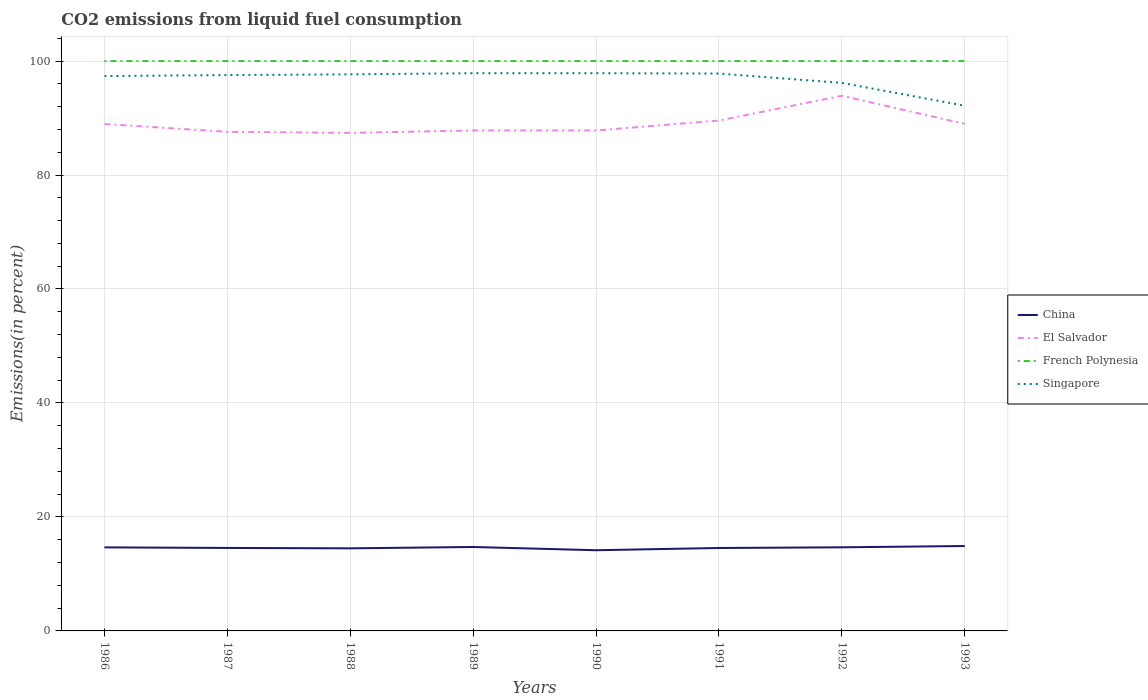How many different coloured lines are there?
Ensure brevity in your answer.  4. Does the line corresponding to Singapore intersect with the line corresponding to China?
Provide a succinct answer. No. Across all years, what is the maximum total CO2 emitted in China?
Your response must be concise. 14.16. What is the total total CO2 emitted in China in the graph?
Ensure brevity in your answer.  -0.34. What is the difference between the highest and the second highest total CO2 emitted in Singapore?
Provide a succinct answer. 5.71. What is the difference between the highest and the lowest total CO2 emitted in China?
Ensure brevity in your answer.  4. What is the difference between two consecutive major ticks on the Y-axis?
Keep it short and to the point. 20. Are the values on the major ticks of Y-axis written in scientific E-notation?
Provide a short and direct response. No. Does the graph contain grids?
Give a very brief answer. Yes. Where does the legend appear in the graph?
Give a very brief answer. Center right. How are the legend labels stacked?
Keep it short and to the point. Vertical. What is the title of the graph?
Give a very brief answer. CO2 emissions from liquid fuel consumption. Does "Turkmenistan" appear as one of the legend labels in the graph?
Provide a succinct answer. No. What is the label or title of the Y-axis?
Offer a very short reply. Emissions(in percent). What is the Emissions(in percent) in China in 1986?
Make the answer very short. 14.66. What is the Emissions(in percent) in El Salvador in 1986?
Offer a terse response. 88.95. What is the Emissions(in percent) in Singapore in 1986?
Your answer should be very brief. 97.36. What is the Emissions(in percent) in China in 1987?
Your answer should be very brief. 14.56. What is the Emissions(in percent) in El Salvador in 1987?
Your answer should be compact. 87.57. What is the Emissions(in percent) of French Polynesia in 1987?
Give a very brief answer. 100. What is the Emissions(in percent) in Singapore in 1987?
Provide a short and direct response. 97.54. What is the Emissions(in percent) of China in 1988?
Keep it short and to the point. 14.49. What is the Emissions(in percent) in El Salvador in 1988?
Your answer should be very brief. 87.39. What is the Emissions(in percent) of Singapore in 1988?
Keep it short and to the point. 97.66. What is the Emissions(in percent) of China in 1989?
Give a very brief answer. 14.73. What is the Emissions(in percent) in El Salvador in 1989?
Make the answer very short. 87.82. What is the Emissions(in percent) of French Polynesia in 1989?
Offer a terse response. 100. What is the Emissions(in percent) of Singapore in 1989?
Provide a succinct answer. 97.86. What is the Emissions(in percent) of China in 1990?
Ensure brevity in your answer.  14.16. What is the Emissions(in percent) in El Salvador in 1990?
Offer a terse response. 87.82. What is the Emissions(in percent) of French Polynesia in 1990?
Ensure brevity in your answer.  100. What is the Emissions(in percent) of Singapore in 1990?
Your response must be concise. 97.87. What is the Emissions(in percent) of China in 1991?
Make the answer very short. 14.55. What is the Emissions(in percent) in El Salvador in 1991?
Provide a succinct answer. 89.56. What is the Emissions(in percent) in French Polynesia in 1991?
Your answer should be very brief. 100. What is the Emissions(in percent) of Singapore in 1991?
Keep it short and to the point. 97.8. What is the Emissions(in percent) in China in 1992?
Ensure brevity in your answer.  14.67. What is the Emissions(in percent) in El Salvador in 1992?
Provide a short and direct response. 93.9. What is the Emissions(in percent) in Singapore in 1992?
Make the answer very short. 96.16. What is the Emissions(in percent) in China in 1993?
Offer a terse response. 14.9. What is the Emissions(in percent) of El Salvador in 1993?
Provide a short and direct response. 88.97. What is the Emissions(in percent) of French Polynesia in 1993?
Ensure brevity in your answer.  100. What is the Emissions(in percent) of Singapore in 1993?
Offer a terse response. 92.15. Across all years, what is the maximum Emissions(in percent) of China?
Provide a short and direct response. 14.9. Across all years, what is the maximum Emissions(in percent) in El Salvador?
Offer a very short reply. 93.9. Across all years, what is the maximum Emissions(in percent) in French Polynesia?
Give a very brief answer. 100. Across all years, what is the maximum Emissions(in percent) in Singapore?
Your response must be concise. 97.87. Across all years, what is the minimum Emissions(in percent) of China?
Provide a short and direct response. 14.16. Across all years, what is the minimum Emissions(in percent) of El Salvador?
Offer a terse response. 87.39. Across all years, what is the minimum Emissions(in percent) in Singapore?
Your answer should be very brief. 92.15. What is the total Emissions(in percent) of China in the graph?
Your response must be concise. 116.73. What is the total Emissions(in percent) of El Salvador in the graph?
Ensure brevity in your answer.  711.98. What is the total Emissions(in percent) of French Polynesia in the graph?
Give a very brief answer. 800. What is the total Emissions(in percent) of Singapore in the graph?
Your response must be concise. 774.41. What is the difference between the Emissions(in percent) in China in 1986 and that in 1987?
Your answer should be very brief. 0.1. What is the difference between the Emissions(in percent) in El Salvador in 1986 and that in 1987?
Make the answer very short. 1.38. What is the difference between the Emissions(in percent) of French Polynesia in 1986 and that in 1987?
Your response must be concise. 0. What is the difference between the Emissions(in percent) in Singapore in 1986 and that in 1987?
Keep it short and to the point. -0.17. What is the difference between the Emissions(in percent) of China in 1986 and that in 1988?
Provide a short and direct response. 0.17. What is the difference between the Emissions(in percent) of El Salvador in 1986 and that in 1988?
Your answer should be compact. 1.56. What is the difference between the Emissions(in percent) of French Polynesia in 1986 and that in 1988?
Give a very brief answer. 0. What is the difference between the Emissions(in percent) in Singapore in 1986 and that in 1988?
Offer a terse response. -0.3. What is the difference between the Emissions(in percent) of China in 1986 and that in 1989?
Your response must be concise. -0.07. What is the difference between the Emissions(in percent) of El Salvador in 1986 and that in 1989?
Make the answer very short. 1.13. What is the difference between the Emissions(in percent) of French Polynesia in 1986 and that in 1989?
Keep it short and to the point. 0. What is the difference between the Emissions(in percent) in Singapore in 1986 and that in 1989?
Provide a succinct answer. -0.5. What is the difference between the Emissions(in percent) in China in 1986 and that in 1990?
Offer a very short reply. 0.5. What is the difference between the Emissions(in percent) in El Salvador in 1986 and that in 1990?
Keep it short and to the point. 1.14. What is the difference between the Emissions(in percent) of French Polynesia in 1986 and that in 1990?
Provide a succinct answer. 0. What is the difference between the Emissions(in percent) in Singapore in 1986 and that in 1990?
Your response must be concise. -0.51. What is the difference between the Emissions(in percent) in China in 1986 and that in 1991?
Keep it short and to the point. 0.11. What is the difference between the Emissions(in percent) in El Salvador in 1986 and that in 1991?
Make the answer very short. -0.61. What is the difference between the Emissions(in percent) in French Polynesia in 1986 and that in 1991?
Your answer should be very brief. 0. What is the difference between the Emissions(in percent) in Singapore in 1986 and that in 1991?
Keep it short and to the point. -0.44. What is the difference between the Emissions(in percent) in China in 1986 and that in 1992?
Provide a succinct answer. -0.01. What is the difference between the Emissions(in percent) in El Salvador in 1986 and that in 1992?
Your response must be concise. -4.95. What is the difference between the Emissions(in percent) in Singapore in 1986 and that in 1992?
Give a very brief answer. 1.2. What is the difference between the Emissions(in percent) of China in 1986 and that in 1993?
Your answer should be compact. -0.24. What is the difference between the Emissions(in percent) in El Salvador in 1986 and that in 1993?
Your response must be concise. -0.02. What is the difference between the Emissions(in percent) of Singapore in 1986 and that in 1993?
Your answer should be very brief. 5.21. What is the difference between the Emissions(in percent) of China in 1987 and that in 1988?
Give a very brief answer. 0.07. What is the difference between the Emissions(in percent) of El Salvador in 1987 and that in 1988?
Your response must be concise. 0.19. What is the difference between the Emissions(in percent) in Singapore in 1987 and that in 1988?
Your answer should be very brief. -0.13. What is the difference between the Emissions(in percent) of China in 1987 and that in 1989?
Your answer should be very brief. -0.17. What is the difference between the Emissions(in percent) in El Salvador in 1987 and that in 1989?
Your answer should be very brief. -0.24. What is the difference between the Emissions(in percent) of Singapore in 1987 and that in 1989?
Your response must be concise. -0.33. What is the difference between the Emissions(in percent) of China in 1987 and that in 1990?
Give a very brief answer. 0.4. What is the difference between the Emissions(in percent) in El Salvador in 1987 and that in 1990?
Offer a very short reply. -0.24. What is the difference between the Emissions(in percent) in Singapore in 1987 and that in 1990?
Your answer should be compact. -0.33. What is the difference between the Emissions(in percent) in China in 1987 and that in 1991?
Provide a succinct answer. 0.01. What is the difference between the Emissions(in percent) of El Salvador in 1987 and that in 1991?
Keep it short and to the point. -1.98. What is the difference between the Emissions(in percent) of Singapore in 1987 and that in 1991?
Make the answer very short. -0.27. What is the difference between the Emissions(in percent) in China in 1987 and that in 1992?
Provide a succinct answer. -0.11. What is the difference between the Emissions(in percent) of El Salvador in 1987 and that in 1992?
Your answer should be very brief. -6.33. What is the difference between the Emissions(in percent) in Singapore in 1987 and that in 1992?
Keep it short and to the point. 1.37. What is the difference between the Emissions(in percent) of China in 1987 and that in 1993?
Make the answer very short. -0.34. What is the difference between the Emissions(in percent) of El Salvador in 1987 and that in 1993?
Offer a terse response. -1.4. What is the difference between the Emissions(in percent) of French Polynesia in 1987 and that in 1993?
Offer a very short reply. 0. What is the difference between the Emissions(in percent) of Singapore in 1987 and that in 1993?
Provide a short and direct response. 5.38. What is the difference between the Emissions(in percent) in China in 1988 and that in 1989?
Your answer should be very brief. -0.24. What is the difference between the Emissions(in percent) of El Salvador in 1988 and that in 1989?
Offer a very short reply. -0.43. What is the difference between the Emissions(in percent) in French Polynesia in 1988 and that in 1989?
Keep it short and to the point. 0. What is the difference between the Emissions(in percent) in Singapore in 1988 and that in 1989?
Provide a succinct answer. -0.2. What is the difference between the Emissions(in percent) in China in 1988 and that in 1990?
Keep it short and to the point. 0.34. What is the difference between the Emissions(in percent) of El Salvador in 1988 and that in 1990?
Provide a succinct answer. -0.43. What is the difference between the Emissions(in percent) in Singapore in 1988 and that in 1990?
Ensure brevity in your answer.  -0.2. What is the difference between the Emissions(in percent) of China in 1988 and that in 1991?
Your answer should be very brief. -0.06. What is the difference between the Emissions(in percent) of El Salvador in 1988 and that in 1991?
Offer a terse response. -2.17. What is the difference between the Emissions(in percent) of Singapore in 1988 and that in 1991?
Keep it short and to the point. -0.14. What is the difference between the Emissions(in percent) of China in 1988 and that in 1992?
Provide a succinct answer. -0.18. What is the difference between the Emissions(in percent) in El Salvador in 1988 and that in 1992?
Provide a succinct answer. -6.51. What is the difference between the Emissions(in percent) of French Polynesia in 1988 and that in 1992?
Your answer should be compact. 0. What is the difference between the Emissions(in percent) in Singapore in 1988 and that in 1992?
Provide a short and direct response. 1.5. What is the difference between the Emissions(in percent) in China in 1988 and that in 1993?
Provide a short and direct response. -0.41. What is the difference between the Emissions(in percent) in El Salvador in 1988 and that in 1993?
Your answer should be very brief. -1.58. What is the difference between the Emissions(in percent) of Singapore in 1988 and that in 1993?
Provide a short and direct response. 5.51. What is the difference between the Emissions(in percent) of China in 1989 and that in 1990?
Offer a terse response. 0.57. What is the difference between the Emissions(in percent) of El Salvador in 1989 and that in 1990?
Provide a short and direct response. 0. What is the difference between the Emissions(in percent) in French Polynesia in 1989 and that in 1990?
Make the answer very short. 0. What is the difference between the Emissions(in percent) of Singapore in 1989 and that in 1990?
Make the answer very short. -0. What is the difference between the Emissions(in percent) in China in 1989 and that in 1991?
Provide a succinct answer. 0.17. What is the difference between the Emissions(in percent) in El Salvador in 1989 and that in 1991?
Your answer should be compact. -1.74. What is the difference between the Emissions(in percent) of Singapore in 1989 and that in 1991?
Provide a short and direct response. 0.06. What is the difference between the Emissions(in percent) in China in 1989 and that in 1992?
Give a very brief answer. 0.06. What is the difference between the Emissions(in percent) of El Salvador in 1989 and that in 1992?
Give a very brief answer. -6.08. What is the difference between the Emissions(in percent) of French Polynesia in 1989 and that in 1992?
Your answer should be very brief. 0. What is the difference between the Emissions(in percent) of Singapore in 1989 and that in 1992?
Make the answer very short. 1.7. What is the difference between the Emissions(in percent) in China in 1989 and that in 1993?
Your answer should be very brief. -0.17. What is the difference between the Emissions(in percent) of El Salvador in 1989 and that in 1993?
Your response must be concise. -1.15. What is the difference between the Emissions(in percent) of Singapore in 1989 and that in 1993?
Provide a succinct answer. 5.71. What is the difference between the Emissions(in percent) in China in 1990 and that in 1991?
Ensure brevity in your answer.  -0.4. What is the difference between the Emissions(in percent) of El Salvador in 1990 and that in 1991?
Provide a succinct answer. -1.74. What is the difference between the Emissions(in percent) in Singapore in 1990 and that in 1991?
Your response must be concise. 0.06. What is the difference between the Emissions(in percent) of China in 1990 and that in 1992?
Your answer should be very brief. -0.51. What is the difference between the Emissions(in percent) of El Salvador in 1990 and that in 1992?
Your response must be concise. -6.09. What is the difference between the Emissions(in percent) of French Polynesia in 1990 and that in 1992?
Your answer should be very brief. 0. What is the difference between the Emissions(in percent) of Singapore in 1990 and that in 1992?
Offer a very short reply. 1.7. What is the difference between the Emissions(in percent) in China in 1990 and that in 1993?
Give a very brief answer. -0.74. What is the difference between the Emissions(in percent) in El Salvador in 1990 and that in 1993?
Provide a short and direct response. -1.16. What is the difference between the Emissions(in percent) of Singapore in 1990 and that in 1993?
Make the answer very short. 5.71. What is the difference between the Emissions(in percent) of China in 1991 and that in 1992?
Give a very brief answer. -0.12. What is the difference between the Emissions(in percent) of El Salvador in 1991 and that in 1992?
Your answer should be very brief. -4.35. What is the difference between the Emissions(in percent) in French Polynesia in 1991 and that in 1992?
Make the answer very short. 0. What is the difference between the Emissions(in percent) of Singapore in 1991 and that in 1992?
Ensure brevity in your answer.  1.64. What is the difference between the Emissions(in percent) of China in 1991 and that in 1993?
Your answer should be very brief. -0.34. What is the difference between the Emissions(in percent) of El Salvador in 1991 and that in 1993?
Make the answer very short. 0.58. What is the difference between the Emissions(in percent) in French Polynesia in 1991 and that in 1993?
Offer a terse response. 0. What is the difference between the Emissions(in percent) of Singapore in 1991 and that in 1993?
Provide a succinct answer. 5.65. What is the difference between the Emissions(in percent) of China in 1992 and that in 1993?
Give a very brief answer. -0.23. What is the difference between the Emissions(in percent) in El Salvador in 1992 and that in 1993?
Offer a very short reply. 4.93. What is the difference between the Emissions(in percent) of Singapore in 1992 and that in 1993?
Give a very brief answer. 4.01. What is the difference between the Emissions(in percent) in China in 1986 and the Emissions(in percent) in El Salvador in 1987?
Provide a short and direct response. -72.91. What is the difference between the Emissions(in percent) of China in 1986 and the Emissions(in percent) of French Polynesia in 1987?
Your answer should be compact. -85.34. What is the difference between the Emissions(in percent) of China in 1986 and the Emissions(in percent) of Singapore in 1987?
Offer a very short reply. -82.88. What is the difference between the Emissions(in percent) of El Salvador in 1986 and the Emissions(in percent) of French Polynesia in 1987?
Your answer should be very brief. -11.05. What is the difference between the Emissions(in percent) of El Salvador in 1986 and the Emissions(in percent) of Singapore in 1987?
Offer a very short reply. -8.59. What is the difference between the Emissions(in percent) of French Polynesia in 1986 and the Emissions(in percent) of Singapore in 1987?
Give a very brief answer. 2.46. What is the difference between the Emissions(in percent) in China in 1986 and the Emissions(in percent) in El Salvador in 1988?
Ensure brevity in your answer.  -72.73. What is the difference between the Emissions(in percent) in China in 1986 and the Emissions(in percent) in French Polynesia in 1988?
Ensure brevity in your answer.  -85.34. What is the difference between the Emissions(in percent) in China in 1986 and the Emissions(in percent) in Singapore in 1988?
Provide a short and direct response. -83. What is the difference between the Emissions(in percent) of El Salvador in 1986 and the Emissions(in percent) of French Polynesia in 1988?
Offer a terse response. -11.05. What is the difference between the Emissions(in percent) in El Salvador in 1986 and the Emissions(in percent) in Singapore in 1988?
Provide a succinct answer. -8.71. What is the difference between the Emissions(in percent) in French Polynesia in 1986 and the Emissions(in percent) in Singapore in 1988?
Ensure brevity in your answer.  2.34. What is the difference between the Emissions(in percent) in China in 1986 and the Emissions(in percent) in El Salvador in 1989?
Provide a short and direct response. -73.16. What is the difference between the Emissions(in percent) in China in 1986 and the Emissions(in percent) in French Polynesia in 1989?
Offer a very short reply. -85.34. What is the difference between the Emissions(in percent) in China in 1986 and the Emissions(in percent) in Singapore in 1989?
Provide a succinct answer. -83.2. What is the difference between the Emissions(in percent) of El Salvador in 1986 and the Emissions(in percent) of French Polynesia in 1989?
Your response must be concise. -11.05. What is the difference between the Emissions(in percent) in El Salvador in 1986 and the Emissions(in percent) in Singapore in 1989?
Your answer should be very brief. -8.91. What is the difference between the Emissions(in percent) in French Polynesia in 1986 and the Emissions(in percent) in Singapore in 1989?
Offer a terse response. 2.14. What is the difference between the Emissions(in percent) of China in 1986 and the Emissions(in percent) of El Salvador in 1990?
Your response must be concise. -73.15. What is the difference between the Emissions(in percent) of China in 1986 and the Emissions(in percent) of French Polynesia in 1990?
Keep it short and to the point. -85.34. What is the difference between the Emissions(in percent) of China in 1986 and the Emissions(in percent) of Singapore in 1990?
Your response must be concise. -83.21. What is the difference between the Emissions(in percent) of El Salvador in 1986 and the Emissions(in percent) of French Polynesia in 1990?
Offer a very short reply. -11.05. What is the difference between the Emissions(in percent) of El Salvador in 1986 and the Emissions(in percent) of Singapore in 1990?
Make the answer very short. -8.92. What is the difference between the Emissions(in percent) of French Polynesia in 1986 and the Emissions(in percent) of Singapore in 1990?
Your answer should be compact. 2.13. What is the difference between the Emissions(in percent) of China in 1986 and the Emissions(in percent) of El Salvador in 1991?
Give a very brief answer. -74.9. What is the difference between the Emissions(in percent) of China in 1986 and the Emissions(in percent) of French Polynesia in 1991?
Your answer should be compact. -85.34. What is the difference between the Emissions(in percent) of China in 1986 and the Emissions(in percent) of Singapore in 1991?
Provide a short and direct response. -83.14. What is the difference between the Emissions(in percent) in El Salvador in 1986 and the Emissions(in percent) in French Polynesia in 1991?
Provide a succinct answer. -11.05. What is the difference between the Emissions(in percent) of El Salvador in 1986 and the Emissions(in percent) of Singapore in 1991?
Your response must be concise. -8.85. What is the difference between the Emissions(in percent) in French Polynesia in 1986 and the Emissions(in percent) in Singapore in 1991?
Ensure brevity in your answer.  2.2. What is the difference between the Emissions(in percent) in China in 1986 and the Emissions(in percent) in El Salvador in 1992?
Provide a succinct answer. -79.24. What is the difference between the Emissions(in percent) of China in 1986 and the Emissions(in percent) of French Polynesia in 1992?
Provide a succinct answer. -85.34. What is the difference between the Emissions(in percent) of China in 1986 and the Emissions(in percent) of Singapore in 1992?
Provide a short and direct response. -81.5. What is the difference between the Emissions(in percent) in El Salvador in 1986 and the Emissions(in percent) in French Polynesia in 1992?
Make the answer very short. -11.05. What is the difference between the Emissions(in percent) in El Salvador in 1986 and the Emissions(in percent) in Singapore in 1992?
Give a very brief answer. -7.21. What is the difference between the Emissions(in percent) of French Polynesia in 1986 and the Emissions(in percent) of Singapore in 1992?
Provide a short and direct response. 3.84. What is the difference between the Emissions(in percent) in China in 1986 and the Emissions(in percent) in El Salvador in 1993?
Your answer should be compact. -74.31. What is the difference between the Emissions(in percent) in China in 1986 and the Emissions(in percent) in French Polynesia in 1993?
Your answer should be compact. -85.34. What is the difference between the Emissions(in percent) in China in 1986 and the Emissions(in percent) in Singapore in 1993?
Make the answer very short. -77.49. What is the difference between the Emissions(in percent) of El Salvador in 1986 and the Emissions(in percent) of French Polynesia in 1993?
Offer a very short reply. -11.05. What is the difference between the Emissions(in percent) of El Salvador in 1986 and the Emissions(in percent) of Singapore in 1993?
Your answer should be compact. -3.2. What is the difference between the Emissions(in percent) of French Polynesia in 1986 and the Emissions(in percent) of Singapore in 1993?
Ensure brevity in your answer.  7.85. What is the difference between the Emissions(in percent) of China in 1987 and the Emissions(in percent) of El Salvador in 1988?
Ensure brevity in your answer.  -72.83. What is the difference between the Emissions(in percent) in China in 1987 and the Emissions(in percent) in French Polynesia in 1988?
Provide a short and direct response. -85.44. What is the difference between the Emissions(in percent) of China in 1987 and the Emissions(in percent) of Singapore in 1988?
Your response must be concise. -83.1. What is the difference between the Emissions(in percent) of El Salvador in 1987 and the Emissions(in percent) of French Polynesia in 1988?
Make the answer very short. -12.43. What is the difference between the Emissions(in percent) in El Salvador in 1987 and the Emissions(in percent) in Singapore in 1988?
Make the answer very short. -10.09. What is the difference between the Emissions(in percent) in French Polynesia in 1987 and the Emissions(in percent) in Singapore in 1988?
Your response must be concise. 2.34. What is the difference between the Emissions(in percent) of China in 1987 and the Emissions(in percent) of El Salvador in 1989?
Offer a terse response. -73.26. What is the difference between the Emissions(in percent) of China in 1987 and the Emissions(in percent) of French Polynesia in 1989?
Offer a terse response. -85.44. What is the difference between the Emissions(in percent) of China in 1987 and the Emissions(in percent) of Singapore in 1989?
Offer a terse response. -83.3. What is the difference between the Emissions(in percent) of El Salvador in 1987 and the Emissions(in percent) of French Polynesia in 1989?
Provide a short and direct response. -12.43. What is the difference between the Emissions(in percent) in El Salvador in 1987 and the Emissions(in percent) in Singapore in 1989?
Keep it short and to the point. -10.29. What is the difference between the Emissions(in percent) of French Polynesia in 1987 and the Emissions(in percent) of Singapore in 1989?
Make the answer very short. 2.14. What is the difference between the Emissions(in percent) in China in 1987 and the Emissions(in percent) in El Salvador in 1990?
Provide a short and direct response. -73.25. What is the difference between the Emissions(in percent) in China in 1987 and the Emissions(in percent) in French Polynesia in 1990?
Ensure brevity in your answer.  -85.44. What is the difference between the Emissions(in percent) of China in 1987 and the Emissions(in percent) of Singapore in 1990?
Offer a terse response. -83.31. What is the difference between the Emissions(in percent) of El Salvador in 1987 and the Emissions(in percent) of French Polynesia in 1990?
Provide a short and direct response. -12.43. What is the difference between the Emissions(in percent) in El Salvador in 1987 and the Emissions(in percent) in Singapore in 1990?
Your response must be concise. -10.29. What is the difference between the Emissions(in percent) in French Polynesia in 1987 and the Emissions(in percent) in Singapore in 1990?
Give a very brief answer. 2.13. What is the difference between the Emissions(in percent) in China in 1987 and the Emissions(in percent) in El Salvador in 1991?
Offer a very short reply. -74.99. What is the difference between the Emissions(in percent) of China in 1987 and the Emissions(in percent) of French Polynesia in 1991?
Offer a terse response. -85.44. What is the difference between the Emissions(in percent) in China in 1987 and the Emissions(in percent) in Singapore in 1991?
Give a very brief answer. -83.24. What is the difference between the Emissions(in percent) of El Salvador in 1987 and the Emissions(in percent) of French Polynesia in 1991?
Make the answer very short. -12.43. What is the difference between the Emissions(in percent) of El Salvador in 1987 and the Emissions(in percent) of Singapore in 1991?
Your response must be concise. -10.23. What is the difference between the Emissions(in percent) of French Polynesia in 1987 and the Emissions(in percent) of Singapore in 1991?
Make the answer very short. 2.2. What is the difference between the Emissions(in percent) of China in 1987 and the Emissions(in percent) of El Salvador in 1992?
Your response must be concise. -79.34. What is the difference between the Emissions(in percent) in China in 1987 and the Emissions(in percent) in French Polynesia in 1992?
Provide a short and direct response. -85.44. What is the difference between the Emissions(in percent) in China in 1987 and the Emissions(in percent) in Singapore in 1992?
Provide a succinct answer. -81.6. What is the difference between the Emissions(in percent) in El Salvador in 1987 and the Emissions(in percent) in French Polynesia in 1992?
Provide a succinct answer. -12.43. What is the difference between the Emissions(in percent) in El Salvador in 1987 and the Emissions(in percent) in Singapore in 1992?
Give a very brief answer. -8.59. What is the difference between the Emissions(in percent) of French Polynesia in 1987 and the Emissions(in percent) of Singapore in 1992?
Provide a succinct answer. 3.84. What is the difference between the Emissions(in percent) in China in 1987 and the Emissions(in percent) in El Salvador in 1993?
Provide a short and direct response. -74.41. What is the difference between the Emissions(in percent) in China in 1987 and the Emissions(in percent) in French Polynesia in 1993?
Your response must be concise. -85.44. What is the difference between the Emissions(in percent) of China in 1987 and the Emissions(in percent) of Singapore in 1993?
Give a very brief answer. -77.59. What is the difference between the Emissions(in percent) in El Salvador in 1987 and the Emissions(in percent) in French Polynesia in 1993?
Offer a very short reply. -12.43. What is the difference between the Emissions(in percent) in El Salvador in 1987 and the Emissions(in percent) in Singapore in 1993?
Your answer should be compact. -4.58. What is the difference between the Emissions(in percent) in French Polynesia in 1987 and the Emissions(in percent) in Singapore in 1993?
Provide a short and direct response. 7.85. What is the difference between the Emissions(in percent) in China in 1988 and the Emissions(in percent) in El Salvador in 1989?
Your answer should be compact. -73.33. What is the difference between the Emissions(in percent) in China in 1988 and the Emissions(in percent) in French Polynesia in 1989?
Provide a short and direct response. -85.51. What is the difference between the Emissions(in percent) in China in 1988 and the Emissions(in percent) in Singapore in 1989?
Ensure brevity in your answer.  -83.37. What is the difference between the Emissions(in percent) of El Salvador in 1988 and the Emissions(in percent) of French Polynesia in 1989?
Ensure brevity in your answer.  -12.61. What is the difference between the Emissions(in percent) in El Salvador in 1988 and the Emissions(in percent) in Singapore in 1989?
Make the answer very short. -10.48. What is the difference between the Emissions(in percent) of French Polynesia in 1988 and the Emissions(in percent) of Singapore in 1989?
Your answer should be compact. 2.14. What is the difference between the Emissions(in percent) in China in 1988 and the Emissions(in percent) in El Salvador in 1990?
Your answer should be compact. -73.32. What is the difference between the Emissions(in percent) of China in 1988 and the Emissions(in percent) of French Polynesia in 1990?
Offer a terse response. -85.51. What is the difference between the Emissions(in percent) of China in 1988 and the Emissions(in percent) of Singapore in 1990?
Offer a terse response. -83.37. What is the difference between the Emissions(in percent) in El Salvador in 1988 and the Emissions(in percent) in French Polynesia in 1990?
Give a very brief answer. -12.61. What is the difference between the Emissions(in percent) of El Salvador in 1988 and the Emissions(in percent) of Singapore in 1990?
Give a very brief answer. -10.48. What is the difference between the Emissions(in percent) of French Polynesia in 1988 and the Emissions(in percent) of Singapore in 1990?
Offer a terse response. 2.13. What is the difference between the Emissions(in percent) in China in 1988 and the Emissions(in percent) in El Salvador in 1991?
Your answer should be very brief. -75.06. What is the difference between the Emissions(in percent) of China in 1988 and the Emissions(in percent) of French Polynesia in 1991?
Keep it short and to the point. -85.51. What is the difference between the Emissions(in percent) of China in 1988 and the Emissions(in percent) of Singapore in 1991?
Offer a terse response. -83.31. What is the difference between the Emissions(in percent) of El Salvador in 1988 and the Emissions(in percent) of French Polynesia in 1991?
Provide a short and direct response. -12.61. What is the difference between the Emissions(in percent) of El Salvador in 1988 and the Emissions(in percent) of Singapore in 1991?
Keep it short and to the point. -10.42. What is the difference between the Emissions(in percent) of French Polynesia in 1988 and the Emissions(in percent) of Singapore in 1991?
Provide a succinct answer. 2.2. What is the difference between the Emissions(in percent) in China in 1988 and the Emissions(in percent) in El Salvador in 1992?
Provide a short and direct response. -79.41. What is the difference between the Emissions(in percent) in China in 1988 and the Emissions(in percent) in French Polynesia in 1992?
Give a very brief answer. -85.51. What is the difference between the Emissions(in percent) of China in 1988 and the Emissions(in percent) of Singapore in 1992?
Your answer should be compact. -81.67. What is the difference between the Emissions(in percent) of El Salvador in 1988 and the Emissions(in percent) of French Polynesia in 1992?
Your answer should be compact. -12.61. What is the difference between the Emissions(in percent) in El Salvador in 1988 and the Emissions(in percent) in Singapore in 1992?
Provide a succinct answer. -8.77. What is the difference between the Emissions(in percent) in French Polynesia in 1988 and the Emissions(in percent) in Singapore in 1992?
Provide a short and direct response. 3.84. What is the difference between the Emissions(in percent) in China in 1988 and the Emissions(in percent) in El Salvador in 1993?
Offer a very short reply. -74.48. What is the difference between the Emissions(in percent) in China in 1988 and the Emissions(in percent) in French Polynesia in 1993?
Your answer should be very brief. -85.51. What is the difference between the Emissions(in percent) of China in 1988 and the Emissions(in percent) of Singapore in 1993?
Keep it short and to the point. -77.66. What is the difference between the Emissions(in percent) in El Salvador in 1988 and the Emissions(in percent) in French Polynesia in 1993?
Keep it short and to the point. -12.61. What is the difference between the Emissions(in percent) in El Salvador in 1988 and the Emissions(in percent) in Singapore in 1993?
Give a very brief answer. -4.76. What is the difference between the Emissions(in percent) of French Polynesia in 1988 and the Emissions(in percent) of Singapore in 1993?
Keep it short and to the point. 7.85. What is the difference between the Emissions(in percent) in China in 1989 and the Emissions(in percent) in El Salvador in 1990?
Offer a very short reply. -73.09. What is the difference between the Emissions(in percent) of China in 1989 and the Emissions(in percent) of French Polynesia in 1990?
Provide a short and direct response. -85.27. What is the difference between the Emissions(in percent) in China in 1989 and the Emissions(in percent) in Singapore in 1990?
Provide a short and direct response. -83.14. What is the difference between the Emissions(in percent) in El Salvador in 1989 and the Emissions(in percent) in French Polynesia in 1990?
Your answer should be compact. -12.18. What is the difference between the Emissions(in percent) in El Salvador in 1989 and the Emissions(in percent) in Singapore in 1990?
Ensure brevity in your answer.  -10.05. What is the difference between the Emissions(in percent) of French Polynesia in 1989 and the Emissions(in percent) of Singapore in 1990?
Offer a very short reply. 2.13. What is the difference between the Emissions(in percent) of China in 1989 and the Emissions(in percent) of El Salvador in 1991?
Offer a terse response. -74.83. What is the difference between the Emissions(in percent) of China in 1989 and the Emissions(in percent) of French Polynesia in 1991?
Offer a terse response. -85.27. What is the difference between the Emissions(in percent) in China in 1989 and the Emissions(in percent) in Singapore in 1991?
Make the answer very short. -83.08. What is the difference between the Emissions(in percent) in El Salvador in 1989 and the Emissions(in percent) in French Polynesia in 1991?
Your answer should be compact. -12.18. What is the difference between the Emissions(in percent) of El Salvador in 1989 and the Emissions(in percent) of Singapore in 1991?
Give a very brief answer. -9.99. What is the difference between the Emissions(in percent) in French Polynesia in 1989 and the Emissions(in percent) in Singapore in 1991?
Your response must be concise. 2.2. What is the difference between the Emissions(in percent) in China in 1989 and the Emissions(in percent) in El Salvador in 1992?
Your answer should be compact. -79.18. What is the difference between the Emissions(in percent) of China in 1989 and the Emissions(in percent) of French Polynesia in 1992?
Your answer should be compact. -85.27. What is the difference between the Emissions(in percent) in China in 1989 and the Emissions(in percent) in Singapore in 1992?
Keep it short and to the point. -81.43. What is the difference between the Emissions(in percent) in El Salvador in 1989 and the Emissions(in percent) in French Polynesia in 1992?
Your answer should be compact. -12.18. What is the difference between the Emissions(in percent) of El Salvador in 1989 and the Emissions(in percent) of Singapore in 1992?
Keep it short and to the point. -8.34. What is the difference between the Emissions(in percent) in French Polynesia in 1989 and the Emissions(in percent) in Singapore in 1992?
Make the answer very short. 3.84. What is the difference between the Emissions(in percent) in China in 1989 and the Emissions(in percent) in El Salvador in 1993?
Ensure brevity in your answer.  -74.24. What is the difference between the Emissions(in percent) of China in 1989 and the Emissions(in percent) of French Polynesia in 1993?
Give a very brief answer. -85.27. What is the difference between the Emissions(in percent) of China in 1989 and the Emissions(in percent) of Singapore in 1993?
Keep it short and to the point. -77.42. What is the difference between the Emissions(in percent) of El Salvador in 1989 and the Emissions(in percent) of French Polynesia in 1993?
Your response must be concise. -12.18. What is the difference between the Emissions(in percent) in El Salvador in 1989 and the Emissions(in percent) in Singapore in 1993?
Make the answer very short. -4.33. What is the difference between the Emissions(in percent) in French Polynesia in 1989 and the Emissions(in percent) in Singapore in 1993?
Ensure brevity in your answer.  7.85. What is the difference between the Emissions(in percent) of China in 1990 and the Emissions(in percent) of El Salvador in 1991?
Offer a terse response. -75.4. What is the difference between the Emissions(in percent) of China in 1990 and the Emissions(in percent) of French Polynesia in 1991?
Provide a short and direct response. -85.84. What is the difference between the Emissions(in percent) of China in 1990 and the Emissions(in percent) of Singapore in 1991?
Keep it short and to the point. -83.65. What is the difference between the Emissions(in percent) of El Salvador in 1990 and the Emissions(in percent) of French Polynesia in 1991?
Provide a short and direct response. -12.18. What is the difference between the Emissions(in percent) in El Salvador in 1990 and the Emissions(in percent) in Singapore in 1991?
Make the answer very short. -9.99. What is the difference between the Emissions(in percent) in French Polynesia in 1990 and the Emissions(in percent) in Singapore in 1991?
Offer a very short reply. 2.2. What is the difference between the Emissions(in percent) of China in 1990 and the Emissions(in percent) of El Salvador in 1992?
Keep it short and to the point. -79.75. What is the difference between the Emissions(in percent) in China in 1990 and the Emissions(in percent) in French Polynesia in 1992?
Provide a short and direct response. -85.84. What is the difference between the Emissions(in percent) of China in 1990 and the Emissions(in percent) of Singapore in 1992?
Ensure brevity in your answer.  -82. What is the difference between the Emissions(in percent) of El Salvador in 1990 and the Emissions(in percent) of French Polynesia in 1992?
Your answer should be compact. -12.18. What is the difference between the Emissions(in percent) in El Salvador in 1990 and the Emissions(in percent) in Singapore in 1992?
Your answer should be very brief. -8.35. What is the difference between the Emissions(in percent) of French Polynesia in 1990 and the Emissions(in percent) of Singapore in 1992?
Your response must be concise. 3.84. What is the difference between the Emissions(in percent) of China in 1990 and the Emissions(in percent) of El Salvador in 1993?
Offer a very short reply. -74.81. What is the difference between the Emissions(in percent) of China in 1990 and the Emissions(in percent) of French Polynesia in 1993?
Keep it short and to the point. -85.84. What is the difference between the Emissions(in percent) in China in 1990 and the Emissions(in percent) in Singapore in 1993?
Make the answer very short. -78. What is the difference between the Emissions(in percent) in El Salvador in 1990 and the Emissions(in percent) in French Polynesia in 1993?
Your response must be concise. -12.18. What is the difference between the Emissions(in percent) in El Salvador in 1990 and the Emissions(in percent) in Singapore in 1993?
Offer a terse response. -4.34. What is the difference between the Emissions(in percent) in French Polynesia in 1990 and the Emissions(in percent) in Singapore in 1993?
Your answer should be compact. 7.85. What is the difference between the Emissions(in percent) of China in 1991 and the Emissions(in percent) of El Salvador in 1992?
Your answer should be compact. -79.35. What is the difference between the Emissions(in percent) in China in 1991 and the Emissions(in percent) in French Polynesia in 1992?
Ensure brevity in your answer.  -85.45. What is the difference between the Emissions(in percent) in China in 1991 and the Emissions(in percent) in Singapore in 1992?
Your answer should be very brief. -81.61. What is the difference between the Emissions(in percent) in El Salvador in 1991 and the Emissions(in percent) in French Polynesia in 1992?
Give a very brief answer. -10.44. What is the difference between the Emissions(in percent) in El Salvador in 1991 and the Emissions(in percent) in Singapore in 1992?
Keep it short and to the point. -6.61. What is the difference between the Emissions(in percent) of French Polynesia in 1991 and the Emissions(in percent) of Singapore in 1992?
Your response must be concise. 3.84. What is the difference between the Emissions(in percent) in China in 1991 and the Emissions(in percent) in El Salvador in 1993?
Your answer should be compact. -74.42. What is the difference between the Emissions(in percent) of China in 1991 and the Emissions(in percent) of French Polynesia in 1993?
Your response must be concise. -85.45. What is the difference between the Emissions(in percent) of China in 1991 and the Emissions(in percent) of Singapore in 1993?
Offer a very short reply. -77.6. What is the difference between the Emissions(in percent) in El Salvador in 1991 and the Emissions(in percent) in French Polynesia in 1993?
Provide a succinct answer. -10.44. What is the difference between the Emissions(in percent) in El Salvador in 1991 and the Emissions(in percent) in Singapore in 1993?
Keep it short and to the point. -2.6. What is the difference between the Emissions(in percent) in French Polynesia in 1991 and the Emissions(in percent) in Singapore in 1993?
Provide a short and direct response. 7.85. What is the difference between the Emissions(in percent) of China in 1992 and the Emissions(in percent) of El Salvador in 1993?
Provide a succinct answer. -74.3. What is the difference between the Emissions(in percent) in China in 1992 and the Emissions(in percent) in French Polynesia in 1993?
Your response must be concise. -85.33. What is the difference between the Emissions(in percent) of China in 1992 and the Emissions(in percent) of Singapore in 1993?
Offer a terse response. -77.48. What is the difference between the Emissions(in percent) of El Salvador in 1992 and the Emissions(in percent) of French Polynesia in 1993?
Offer a terse response. -6.1. What is the difference between the Emissions(in percent) of El Salvador in 1992 and the Emissions(in percent) of Singapore in 1993?
Your response must be concise. 1.75. What is the difference between the Emissions(in percent) of French Polynesia in 1992 and the Emissions(in percent) of Singapore in 1993?
Your answer should be very brief. 7.85. What is the average Emissions(in percent) in China per year?
Your response must be concise. 14.59. What is the average Emissions(in percent) in El Salvador per year?
Your answer should be compact. 89. What is the average Emissions(in percent) of French Polynesia per year?
Provide a succinct answer. 100. What is the average Emissions(in percent) of Singapore per year?
Ensure brevity in your answer.  96.8. In the year 1986, what is the difference between the Emissions(in percent) in China and Emissions(in percent) in El Salvador?
Give a very brief answer. -74.29. In the year 1986, what is the difference between the Emissions(in percent) of China and Emissions(in percent) of French Polynesia?
Ensure brevity in your answer.  -85.34. In the year 1986, what is the difference between the Emissions(in percent) of China and Emissions(in percent) of Singapore?
Your response must be concise. -82.7. In the year 1986, what is the difference between the Emissions(in percent) of El Salvador and Emissions(in percent) of French Polynesia?
Ensure brevity in your answer.  -11.05. In the year 1986, what is the difference between the Emissions(in percent) in El Salvador and Emissions(in percent) in Singapore?
Offer a very short reply. -8.41. In the year 1986, what is the difference between the Emissions(in percent) of French Polynesia and Emissions(in percent) of Singapore?
Make the answer very short. 2.64. In the year 1987, what is the difference between the Emissions(in percent) in China and Emissions(in percent) in El Salvador?
Your answer should be compact. -73.01. In the year 1987, what is the difference between the Emissions(in percent) of China and Emissions(in percent) of French Polynesia?
Provide a succinct answer. -85.44. In the year 1987, what is the difference between the Emissions(in percent) of China and Emissions(in percent) of Singapore?
Your response must be concise. -82.97. In the year 1987, what is the difference between the Emissions(in percent) in El Salvador and Emissions(in percent) in French Polynesia?
Make the answer very short. -12.43. In the year 1987, what is the difference between the Emissions(in percent) in El Salvador and Emissions(in percent) in Singapore?
Your answer should be compact. -9.96. In the year 1987, what is the difference between the Emissions(in percent) in French Polynesia and Emissions(in percent) in Singapore?
Keep it short and to the point. 2.46. In the year 1988, what is the difference between the Emissions(in percent) of China and Emissions(in percent) of El Salvador?
Provide a succinct answer. -72.9. In the year 1988, what is the difference between the Emissions(in percent) of China and Emissions(in percent) of French Polynesia?
Offer a very short reply. -85.51. In the year 1988, what is the difference between the Emissions(in percent) in China and Emissions(in percent) in Singapore?
Keep it short and to the point. -83.17. In the year 1988, what is the difference between the Emissions(in percent) in El Salvador and Emissions(in percent) in French Polynesia?
Give a very brief answer. -12.61. In the year 1988, what is the difference between the Emissions(in percent) of El Salvador and Emissions(in percent) of Singapore?
Your answer should be compact. -10.28. In the year 1988, what is the difference between the Emissions(in percent) in French Polynesia and Emissions(in percent) in Singapore?
Offer a terse response. 2.34. In the year 1989, what is the difference between the Emissions(in percent) in China and Emissions(in percent) in El Salvador?
Keep it short and to the point. -73.09. In the year 1989, what is the difference between the Emissions(in percent) of China and Emissions(in percent) of French Polynesia?
Keep it short and to the point. -85.27. In the year 1989, what is the difference between the Emissions(in percent) in China and Emissions(in percent) in Singapore?
Your answer should be very brief. -83.14. In the year 1989, what is the difference between the Emissions(in percent) of El Salvador and Emissions(in percent) of French Polynesia?
Make the answer very short. -12.18. In the year 1989, what is the difference between the Emissions(in percent) of El Salvador and Emissions(in percent) of Singapore?
Make the answer very short. -10.05. In the year 1989, what is the difference between the Emissions(in percent) in French Polynesia and Emissions(in percent) in Singapore?
Ensure brevity in your answer.  2.14. In the year 1990, what is the difference between the Emissions(in percent) in China and Emissions(in percent) in El Salvador?
Provide a short and direct response. -73.66. In the year 1990, what is the difference between the Emissions(in percent) in China and Emissions(in percent) in French Polynesia?
Ensure brevity in your answer.  -85.84. In the year 1990, what is the difference between the Emissions(in percent) of China and Emissions(in percent) of Singapore?
Your answer should be compact. -83.71. In the year 1990, what is the difference between the Emissions(in percent) in El Salvador and Emissions(in percent) in French Polynesia?
Give a very brief answer. -12.18. In the year 1990, what is the difference between the Emissions(in percent) of El Salvador and Emissions(in percent) of Singapore?
Your response must be concise. -10.05. In the year 1990, what is the difference between the Emissions(in percent) in French Polynesia and Emissions(in percent) in Singapore?
Give a very brief answer. 2.13. In the year 1991, what is the difference between the Emissions(in percent) of China and Emissions(in percent) of El Salvador?
Give a very brief answer. -75. In the year 1991, what is the difference between the Emissions(in percent) of China and Emissions(in percent) of French Polynesia?
Give a very brief answer. -85.45. In the year 1991, what is the difference between the Emissions(in percent) of China and Emissions(in percent) of Singapore?
Your response must be concise. -83.25. In the year 1991, what is the difference between the Emissions(in percent) of El Salvador and Emissions(in percent) of French Polynesia?
Keep it short and to the point. -10.44. In the year 1991, what is the difference between the Emissions(in percent) of El Salvador and Emissions(in percent) of Singapore?
Make the answer very short. -8.25. In the year 1991, what is the difference between the Emissions(in percent) in French Polynesia and Emissions(in percent) in Singapore?
Ensure brevity in your answer.  2.2. In the year 1992, what is the difference between the Emissions(in percent) in China and Emissions(in percent) in El Salvador?
Make the answer very short. -79.23. In the year 1992, what is the difference between the Emissions(in percent) in China and Emissions(in percent) in French Polynesia?
Your response must be concise. -85.33. In the year 1992, what is the difference between the Emissions(in percent) of China and Emissions(in percent) of Singapore?
Your answer should be compact. -81.49. In the year 1992, what is the difference between the Emissions(in percent) of El Salvador and Emissions(in percent) of French Polynesia?
Your answer should be very brief. -6.1. In the year 1992, what is the difference between the Emissions(in percent) of El Salvador and Emissions(in percent) of Singapore?
Your answer should be compact. -2.26. In the year 1992, what is the difference between the Emissions(in percent) of French Polynesia and Emissions(in percent) of Singapore?
Ensure brevity in your answer.  3.84. In the year 1993, what is the difference between the Emissions(in percent) of China and Emissions(in percent) of El Salvador?
Offer a terse response. -74.07. In the year 1993, what is the difference between the Emissions(in percent) of China and Emissions(in percent) of French Polynesia?
Ensure brevity in your answer.  -85.1. In the year 1993, what is the difference between the Emissions(in percent) in China and Emissions(in percent) in Singapore?
Offer a terse response. -77.25. In the year 1993, what is the difference between the Emissions(in percent) in El Salvador and Emissions(in percent) in French Polynesia?
Ensure brevity in your answer.  -11.03. In the year 1993, what is the difference between the Emissions(in percent) in El Salvador and Emissions(in percent) in Singapore?
Provide a succinct answer. -3.18. In the year 1993, what is the difference between the Emissions(in percent) in French Polynesia and Emissions(in percent) in Singapore?
Give a very brief answer. 7.85. What is the ratio of the Emissions(in percent) of El Salvador in 1986 to that in 1987?
Give a very brief answer. 1.02. What is the ratio of the Emissions(in percent) in China in 1986 to that in 1988?
Ensure brevity in your answer.  1.01. What is the ratio of the Emissions(in percent) of El Salvador in 1986 to that in 1988?
Give a very brief answer. 1.02. What is the ratio of the Emissions(in percent) in China in 1986 to that in 1989?
Your response must be concise. 1. What is the ratio of the Emissions(in percent) in El Salvador in 1986 to that in 1989?
Keep it short and to the point. 1.01. What is the ratio of the Emissions(in percent) in China in 1986 to that in 1990?
Provide a short and direct response. 1.04. What is the ratio of the Emissions(in percent) of El Salvador in 1986 to that in 1990?
Provide a succinct answer. 1.01. What is the ratio of the Emissions(in percent) of French Polynesia in 1986 to that in 1990?
Keep it short and to the point. 1. What is the ratio of the Emissions(in percent) in Singapore in 1986 to that in 1990?
Offer a terse response. 0.99. What is the ratio of the Emissions(in percent) in China in 1986 to that in 1991?
Give a very brief answer. 1.01. What is the ratio of the Emissions(in percent) in French Polynesia in 1986 to that in 1991?
Keep it short and to the point. 1. What is the ratio of the Emissions(in percent) in Singapore in 1986 to that in 1991?
Provide a short and direct response. 1. What is the ratio of the Emissions(in percent) in China in 1986 to that in 1992?
Make the answer very short. 1. What is the ratio of the Emissions(in percent) in El Salvador in 1986 to that in 1992?
Your answer should be compact. 0.95. What is the ratio of the Emissions(in percent) in Singapore in 1986 to that in 1992?
Give a very brief answer. 1.01. What is the ratio of the Emissions(in percent) of El Salvador in 1986 to that in 1993?
Your answer should be compact. 1. What is the ratio of the Emissions(in percent) of French Polynesia in 1986 to that in 1993?
Offer a very short reply. 1. What is the ratio of the Emissions(in percent) in Singapore in 1986 to that in 1993?
Offer a terse response. 1.06. What is the ratio of the Emissions(in percent) in China in 1987 to that in 1988?
Keep it short and to the point. 1. What is the ratio of the Emissions(in percent) of French Polynesia in 1987 to that in 1988?
Your answer should be very brief. 1. What is the ratio of the Emissions(in percent) in Singapore in 1987 to that in 1988?
Your answer should be compact. 1. What is the ratio of the Emissions(in percent) in China in 1987 to that in 1989?
Keep it short and to the point. 0.99. What is the ratio of the Emissions(in percent) in El Salvador in 1987 to that in 1989?
Offer a very short reply. 1. What is the ratio of the Emissions(in percent) in French Polynesia in 1987 to that in 1989?
Offer a terse response. 1. What is the ratio of the Emissions(in percent) in Singapore in 1987 to that in 1989?
Offer a very short reply. 1. What is the ratio of the Emissions(in percent) of China in 1987 to that in 1990?
Keep it short and to the point. 1.03. What is the ratio of the Emissions(in percent) in El Salvador in 1987 to that in 1990?
Your answer should be compact. 1. What is the ratio of the Emissions(in percent) of French Polynesia in 1987 to that in 1990?
Your answer should be very brief. 1. What is the ratio of the Emissions(in percent) in El Salvador in 1987 to that in 1991?
Offer a very short reply. 0.98. What is the ratio of the Emissions(in percent) of Singapore in 1987 to that in 1991?
Ensure brevity in your answer.  1. What is the ratio of the Emissions(in percent) of China in 1987 to that in 1992?
Ensure brevity in your answer.  0.99. What is the ratio of the Emissions(in percent) of El Salvador in 1987 to that in 1992?
Offer a very short reply. 0.93. What is the ratio of the Emissions(in percent) in Singapore in 1987 to that in 1992?
Make the answer very short. 1.01. What is the ratio of the Emissions(in percent) in China in 1987 to that in 1993?
Keep it short and to the point. 0.98. What is the ratio of the Emissions(in percent) of El Salvador in 1987 to that in 1993?
Your response must be concise. 0.98. What is the ratio of the Emissions(in percent) of French Polynesia in 1987 to that in 1993?
Offer a terse response. 1. What is the ratio of the Emissions(in percent) of Singapore in 1987 to that in 1993?
Offer a very short reply. 1.06. What is the ratio of the Emissions(in percent) in El Salvador in 1988 to that in 1989?
Your response must be concise. 1. What is the ratio of the Emissions(in percent) of Singapore in 1988 to that in 1989?
Offer a very short reply. 1. What is the ratio of the Emissions(in percent) in China in 1988 to that in 1990?
Your answer should be compact. 1.02. What is the ratio of the Emissions(in percent) of El Salvador in 1988 to that in 1990?
Make the answer very short. 1. What is the ratio of the Emissions(in percent) of French Polynesia in 1988 to that in 1990?
Provide a short and direct response. 1. What is the ratio of the Emissions(in percent) in China in 1988 to that in 1991?
Offer a terse response. 1. What is the ratio of the Emissions(in percent) of El Salvador in 1988 to that in 1991?
Provide a short and direct response. 0.98. What is the ratio of the Emissions(in percent) in French Polynesia in 1988 to that in 1991?
Ensure brevity in your answer.  1. What is the ratio of the Emissions(in percent) in China in 1988 to that in 1992?
Keep it short and to the point. 0.99. What is the ratio of the Emissions(in percent) in El Salvador in 1988 to that in 1992?
Give a very brief answer. 0.93. What is the ratio of the Emissions(in percent) of French Polynesia in 1988 to that in 1992?
Keep it short and to the point. 1. What is the ratio of the Emissions(in percent) in Singapore in 1988 to that in 1992?
Make the answer very short. 1.02. What is the ratio of the Emissions(in percent) of China in 1988 to that in 1993?
Keep it short and to the point. 0.97. What is the ratio of the Emissions(in percent) of El Salvador in 1988 to that in 1993?
Make the answer very short. 0.98. What is the ratio of the Emissions(in percent) in French Polynesia in 1988 to that in 1993?
Make the answer very short. 1. What is the ratio of the Emissions(in percent) in Singapore in 1988 to that in 1993?
Provide a short and direct response. 1.06. What is the ratio of the Emissions(in percent) in China in 1989 to that in 1990?
Offer a very short reply. 1.04. What is the ratio of the Emissions(in percent) of French Polynesia in 1989 to that in 1990?
Provide a succinct answer. 1. What is the ratio of the Emissions(in percent) in Singapore in 1989 to that in 1990?
Make the answer very short. 1. What is the ratio of the Emissions(in percent) in China in 1989 to that in 1991?
Ensure brevity in your answer.  1.01. What is the ratio of the Emissions(in percent) in El Salvador in 1989 to that in 1991?
Make the answer very short. 0.98. What is the ratio of the Emissions(in percent) of French Polynesia in 1989 to that in 1991?
Ensure brevity in your answer.  1. What is the ratio of the Emissions(in percent) in China in 1989 to that in 1992?
Give a very brief answer. 1. What is the ratio of the Emissions(in percent) of El Salvador in 1989 to that in 1992?
Provide a succinct answer. 0.94. What is the ratio of the Emissions(in percent) in French Polynesia in 1989 to that in 1992?
Give a very brief answer. 1. What is the ratio of the Emissions(in percent) of Singapore in 1989 to that in 1992?
Offer a terse response. 1.02. What is the ratio of the Emissions(in percent) in El Salvador in 1989 to that in 1993?
Give a very brief answer. 0.99. What is the ratio of the Emissions(in percent) of Singapore in 1989 to that in 1993?
Offer a terse response. 1.06. What is the ratio of the Emissions(in percent) of China in 1990 to that in 1991?
Provide a short and direct response. 0.97. What is the ratio of the Emissions(in percent) in El Salvador in 1990 to that in 1991?
Keep it short and to the point. 0.98. What is the ratio of the Emissions(in percent) in French Polynesia in 1990 to that in 1991?
Keep it short and to the point. 1. What is the ratio of the Emissions(in percent) of Singapore in 1990 to that in 1991?
Your response must be concise. 1. What is the ratio of the Emissions(in percent) of El Salvador in 1990 to that in 1992?
Provide a succinct answer. 0.94. What is the ratio of the Emissions(in percent) in French Polynesia in 1990 to that in 1992?
Your answer should be compact. 1. What is the ratio of the Emissions(in percent) of Singapore in 1990 to that in 1992?
Your answer should be compact. 1.02. What is the ratio of the Emissions(in percent) of China in 1990 to that in 1993?
Your answer should be very brief. 0.95. What is the ratio of the Emissions(in percent) of El Salvador in 1990 to that in 1993?
Keep it short and to the point. 0.99. What is the ratio of the Emissions(in percent) of French Polynesia in 1990 to that in 1993?
Make the answer very short. 1. What is the ratio of the Emissions(in percent) of Singapore in 1990 to that in 1993?
Your response must be concise. 1.06. What is the ratio of the Emissions(in percent) of China in 1991 to that in 1992?
Give a very brief answer. 0.99. What is the ratio of the Emissions(in percent) in El Salvador in 1991 to that in 1992?
Give a very brief answer. 0.95. What is the ratio of the Emissions(in percent) of Singapore in 1991 to that in 1992?
Your answer should be very brief. 1.02. What is the ratio of the Emissions(in percent) in China in 1991 to that in 1993?
Make the answer very short. 0.98. What is the ratio of the Emissions(in percent) in El Salvador in 1991 to that in 1993?
Provide a succinct answer. 1.01. What is the ratio of the Emissions(in percent) of French Polynesia in 1991 to that in 1993?
Offer a very short reply. 1. What is the ratio of the Emissions(in percent) of Singapore in 1991 to that in 1993?
Ensure brevity in your answer.  1.06. What is the ratio of the Emissions(in percent) in El Salvador in 1992 to that in 1993?
Offer a very short reply. 1.06. What is the ratio of the Emissions(in percent) in French Polynesia in 1992 to that in 1993?
Give a very brief answer. 1. What is the ratio of the Emissions(in percent) in Singapore in 1992 to that in 1993?
Make the answer very short. 1.04. What is the difference between the highest and the second highest Emissions(in percent) in China?
Provide a short and direct response. 0.17. What is the difference between the highest and the second highest Emissions(in percent) in El Salvador?
Make the answer very short. 4.35. What is the difference between the highest and the second highest Emissions(in percent) of French Polynesia?
Your answer should be very brief. 0. What is the difference between the highest and the second highest Emissions(in percent) in Singapore?
Your answer should be very brief. 0. What is the difference between the highest and the lowest Emissions(in percent) of China?
Your answer should be very brief. 0.74. What is the difference between the highest and the lowest Emissions(in percent) in El Salvador?
Give a very brief answer. 6.51. What is the difference between the highest and the lowest Emissions(in percent) of Singapore?
Provide a succinct answer. 5.71. 